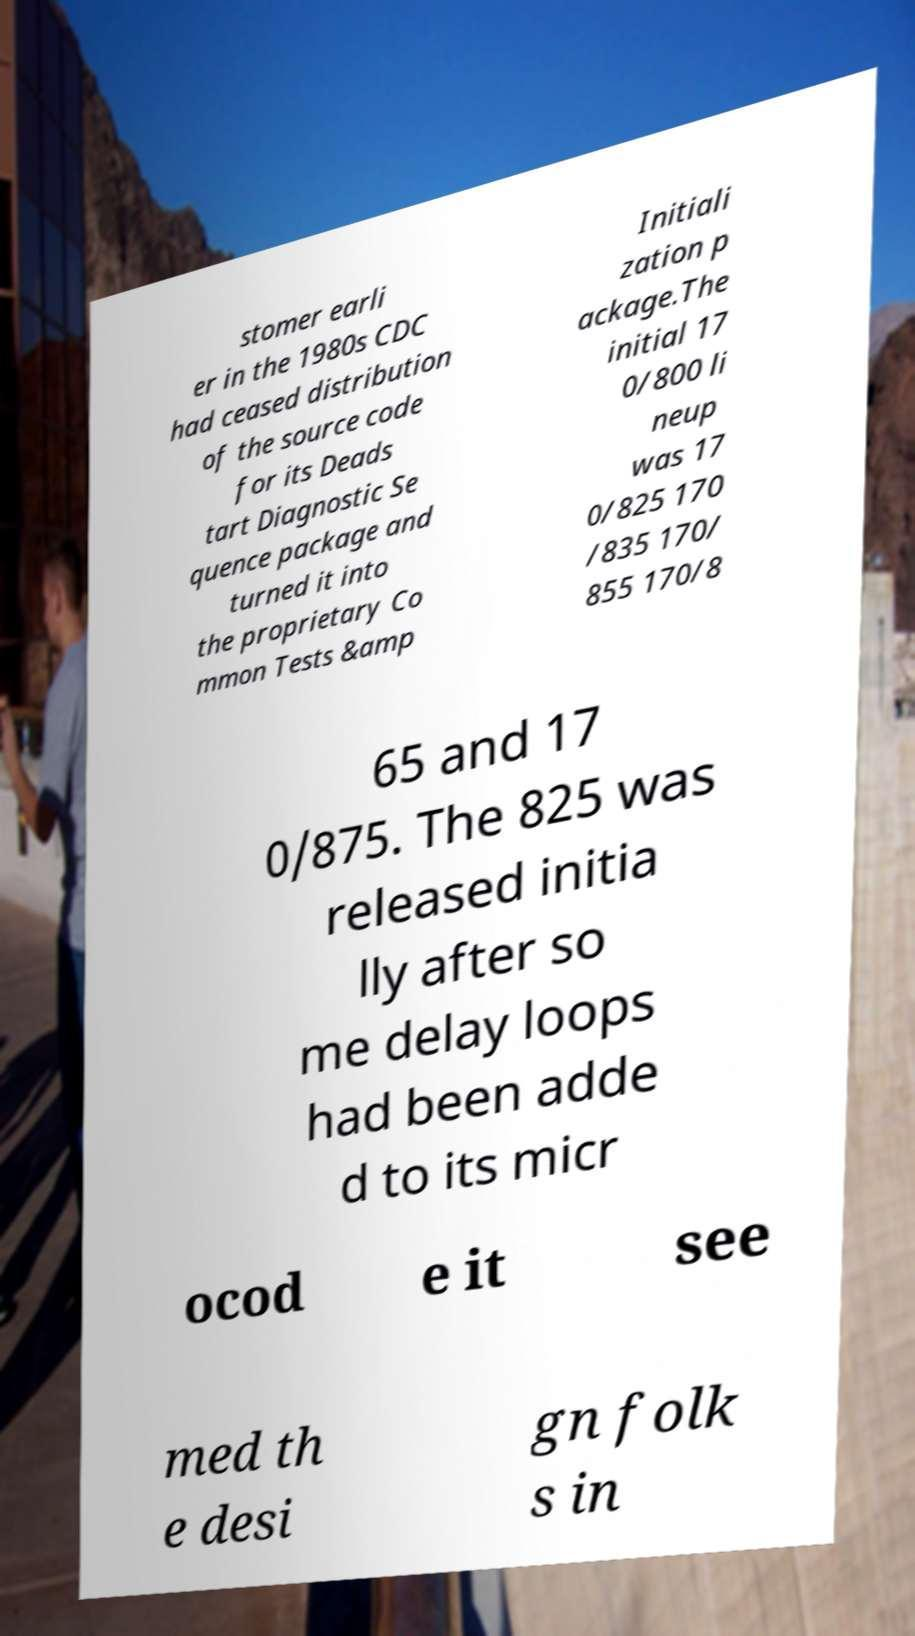Please identify and transcribe the text found in this image. stomer earli er in the 1980s CDC had ceased distribution of the source code for its Deads tart Diagnostic Se quence package and turned it into the proprietary Co mmon Tests &amp Initiali zation p ackage.The initial 17 0/800 li neup was 17 0/825 170 /835 170/ 855 170/8 65 and 17 0/875. The 825 was released initia lly after so me delay loops had been adde d to its micr ocod e it see med th e desi gn folk s in 